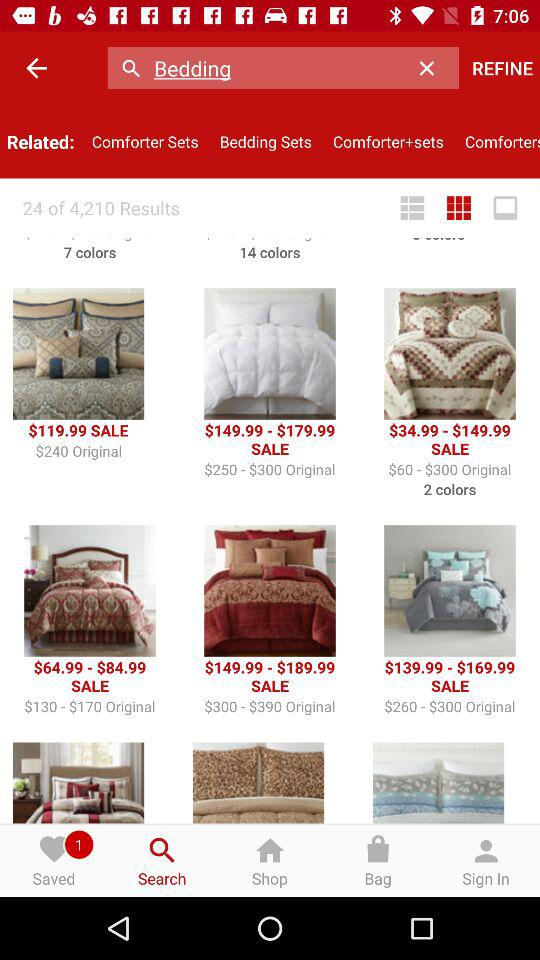How many items are saved? There is 1 saved item. 